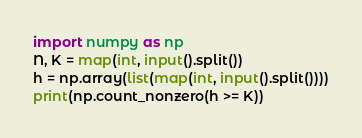<code> <loc_0><loc_0><loc_500><loc_500><_Python_>import numpy as np
N, K = map(int, input().split())
h = np.array(list(map(int, input().split())))
print(np.count_nonzero(h >= K))
</code> 